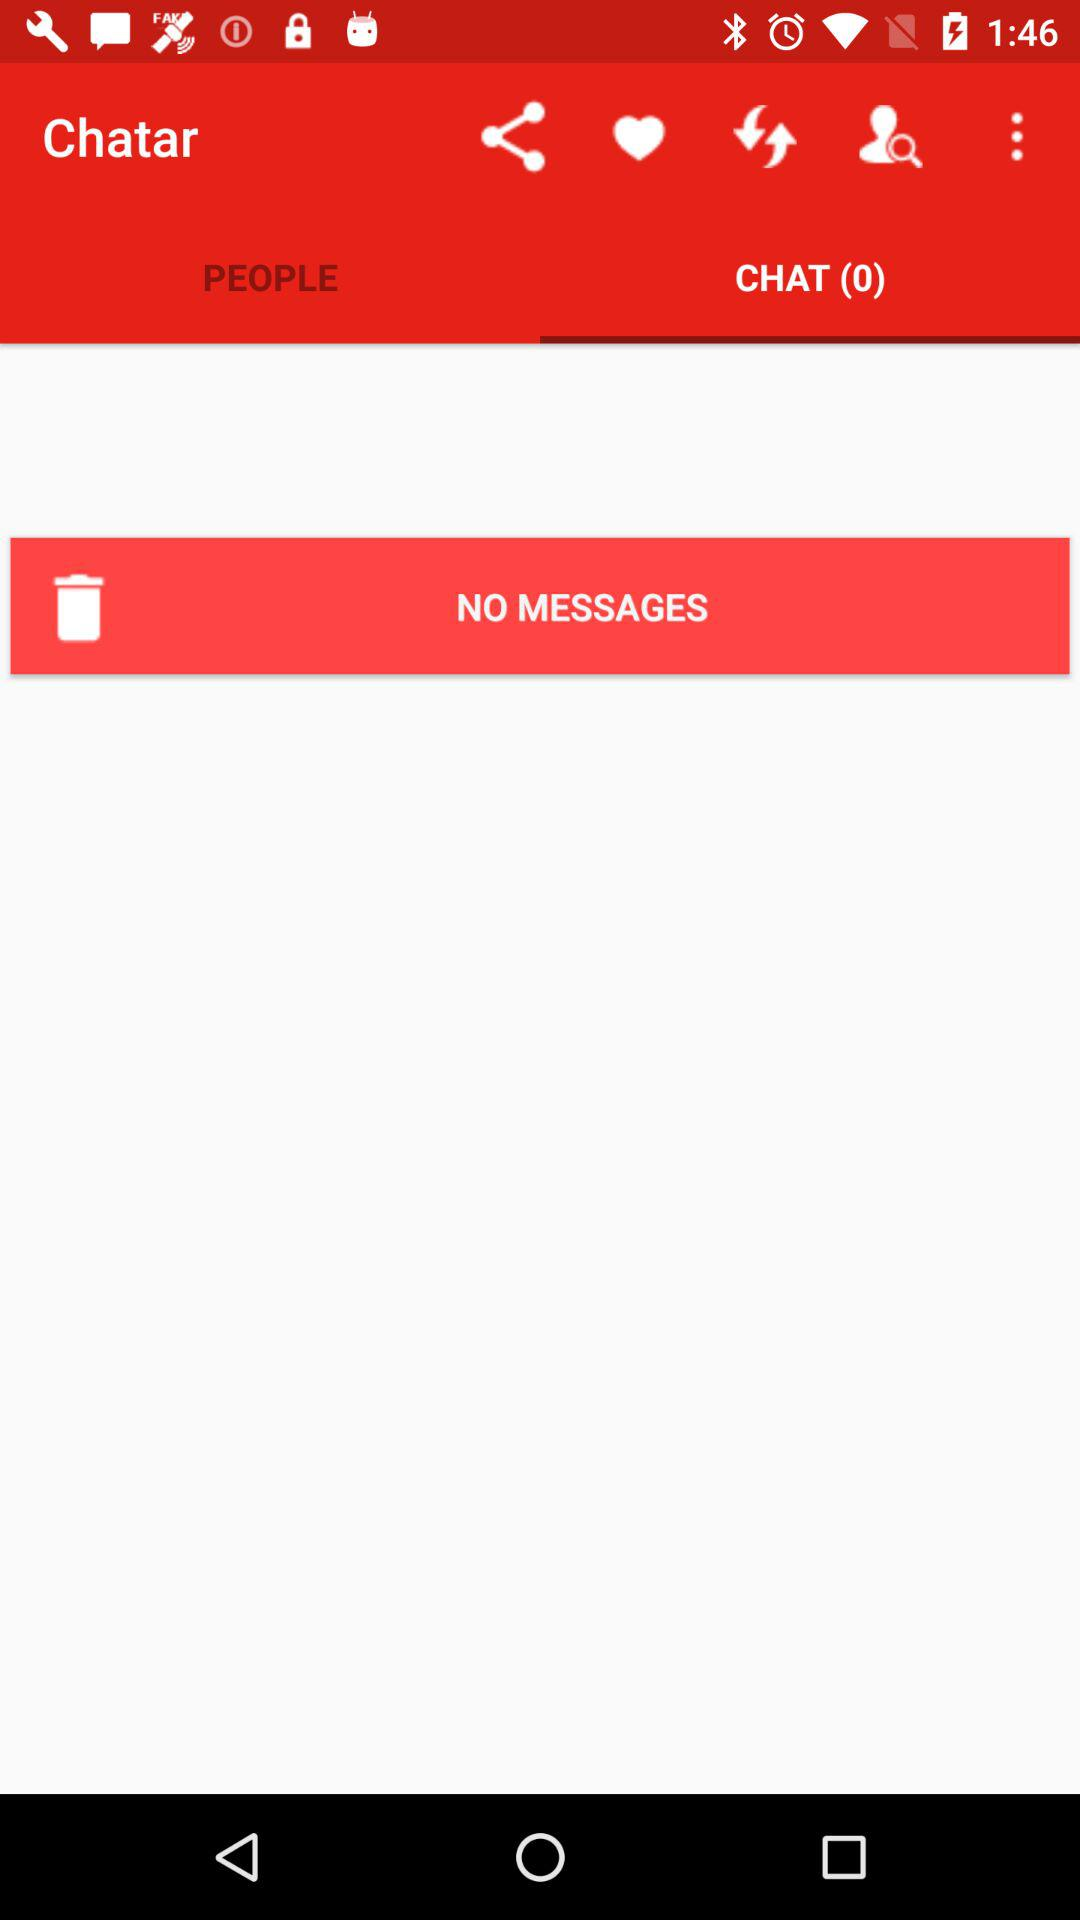Are there any messages on the screen? There are no messages on the screen. 